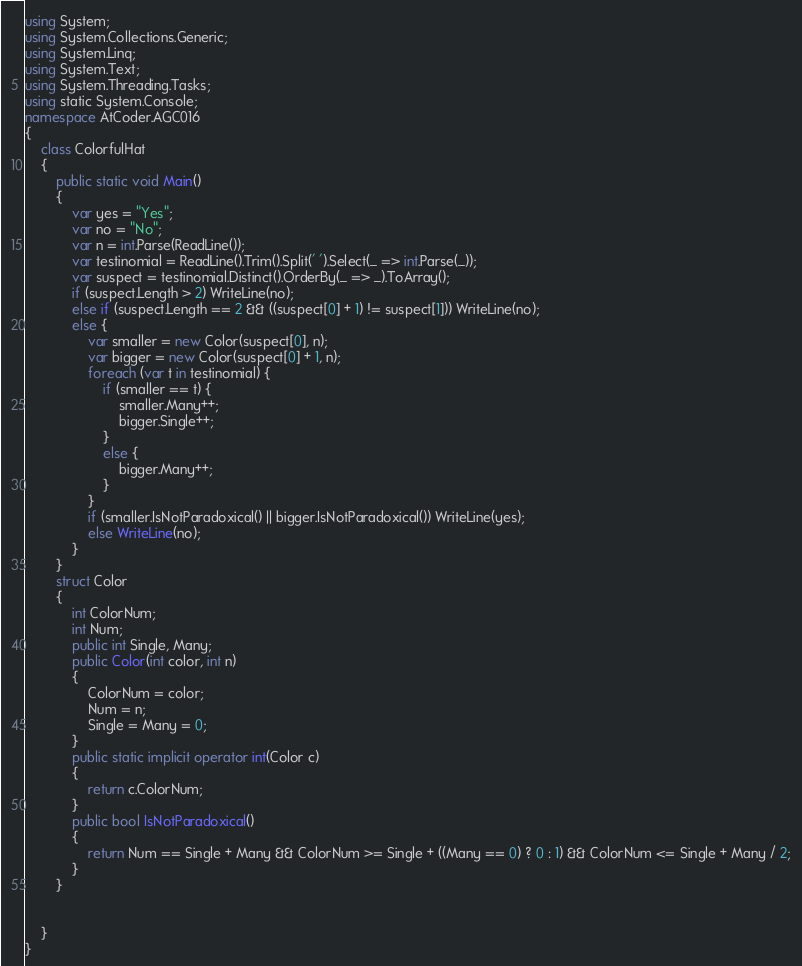<code> <loc_0><loc_0><loc_500><loc_500><_C#_>using System;
using System.Collections.Generic;
using System.Linq;
using System.Text;
using System.Threading.Tasks;
using static System.Console;
namespace AtCoder.AGC016
{
    class ColorfulHat
    {
        public static void Main()
        {
            var yes = "Yes";
            var no = "No";
            var n = int.Parse(ReadLine());
            var testinomial = ReadLine().Trim().Split(' ').Select(_ => int.Parse(_));
            var suspect = testinomial.Distinct().OrderBy(_ => _).ToArray();
            if (suspect.Length > 2) WriteLine(no);
            else if (suspect.Length == 2 && ((suspect[0] + 1) != suspect[1])) WriteLine(no);
            else {
                var smaller = new Color(suspect[0], n);
                var bigger = new Color(suspect[0] + 1, n);
                foreach (var t in testinomial) {
                    if (smaller == t) {
                        smaller.Many++;
                        bigger.Single++;
                    }
                    else {
                        bigger.Many++;
                    }
                }
                if (smaller.IsNotParadoxical() || bigger.IsNotParadoxical()) WriteLine(yes);
                else WriteLine(no);
            }
        }
        struct Color
        {
            int ColorNum;
            int Num;
            public int Single, Many;
            public Color(int color, int n)
            {
                ColorNum = color;
                Num = n;
                Single = Many = 0;
            }
            public static implicit operator int(Color c)
            {
                return c.ColorNum;
            }
            public bool IsNotParadoxical()
            {
                return Num == Single + Many && ColorNum >= Single + ((Many == 0) ? 0 : 1) && ColorNum <= Single + Many / 2;
            }
        }


    }
}
</code> 